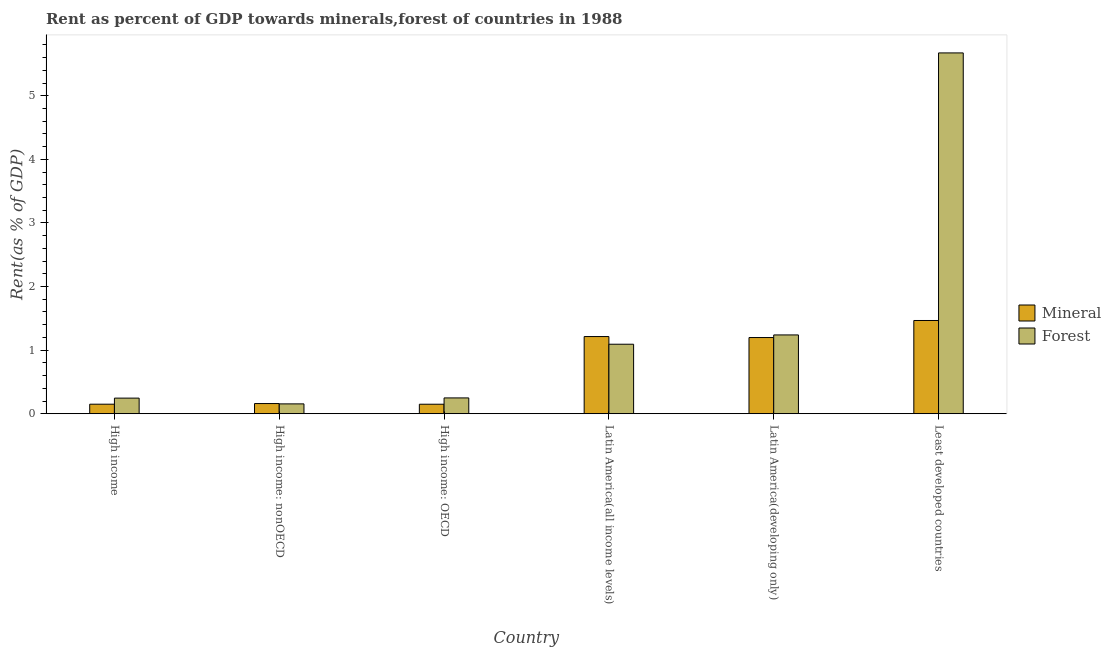How many bars are there on the 5th tick from the left?
Your answer should be compact. 2. How many bars are there on the 5th tick from the right?
Offer a very short reply. 2. What is the label of the 5th group of bars from the left?
Your response must be concise. Latin America(developing only). What is the mineral rent in High income?
Make the answer very short. 0.15. Across all countries, what is the maximum mineral rent?
Your response must be concise. 1.47. Across all countries, what is the minimum forest rent?
Offer a very short reply. 0.16. In which country was the forest rent maximum?
Your answer should be compact. Least developed countries. In which country was the forest rent minimum?
Provide a short and direct response. High income: nonOECD. What is the total forest rent in the graph?
Make the answer very short. 8.65. What is the difference between the mineral rent in High income: OECD and that in Least developed countries?
Keep it short and to the point. -1.32. What is the difference between the forest rent in Latin America(all income levels) and the mineral rent in Latin America(developing only)?
Your response must be concise. -0.11. What is the average mineral rent per country?
Provide a short and direct response. 0.72. What is the difference between the forest rent and mineral rent in High income: nonOECD?
Your response must be concise. -0.01. In how many countries, is the forest rent greater than 2 %?
Your answer should be compact. 1. What is the ratio of the mineral rent in High income to that in High income: nonOECD?
Provide a succinct answer. 0.94. Is the mineral rent in High income less than that in Least developed countries?
Ensure brevity in your answer.  Yes. Is the difference between the forest rent in High income and High income: nonOECD greater than the difference between the mineral rent in High income and High income: nonOECD?
Keep it short and to the point. Yes. What is the difference between the highest and the second highest forest rent?
Give a very brief answer. 4.43. What is the difference between the highest and the lowest forest rent?
Your answer should be compact. 5.52. What does the 1st bar from the left in Latin America(developing only) represents?
Your answer should be compact. Mineral. What does the 1st bar from the right in Latin America(developing only) represents?
Your answer should be very brief. Forest. How many countries are there in the graph?
Keep it short and to the point. 6. What is the difference between two consecutive major ticks on the Y-axis?
Keep it short and to the point. 1. Where does the legend appear in the graph?
Keep it short and to the point. Center right. How many legend labels are there?
Provide a succinct answer. 2. How are the legend labels stacked?
Offer a very short reply. Vertical. What is the title of the graph?
Provide a succinct answer. Rent as percent of GDP towards minerals,forest of countries in 1988. Does "Depositors" appear as one of the legend labels in the graph?
Provide a short and direct response. No. What is the label or title of the Y-axis?
Provide a succinct answer. Rent(as % of GDP). What is the Rent(as % of GDP) in Mineral in High income?
Ensure brevity in your answer.  0.15. What is the Rent(as % of GDP) in Forest in High income?
Offer a terse response. 0.25. What is the Rent(as % of GDP) in Mineral in High income: nonOECD?
Offer a very short reply. 0.16. What is the Rent(as % of GDP) of Forest in High income: nonOECD?
Your answer should be compact. 0.16. What is the Rent(as % of GDP) of Mineral in High income: OECD?
Make the answer very short. 0.15. What is the Rent(as % of GDP) of Forest in High income: OECD?
Give a very brief answer. 0.25. What is the Rent(as % of GDP) in Mineral in Latin America(all income levels)?
Provide a short and direct response. 1.21. What is the Rent(as % of GDP) in Forest in Latin America(all income levels)?
Give a very brief answer. 1.09. What is the Rent(as % of GDP) in Mineral in Latin America(developing only)?
Make the answer very short. 1.2. What is the Rent(as % of GDP) in Forest in Latin America(developing only)?
Offer a terse response. 1.24. What is the Rent(as % of GDP) of Mineral in Least developed countries?
Provide a succinct answer. 1.47. What is the Rent(as % of GDP) of Forest in Least developed countries?
Make the answer very short. 5.67. Across all countries, what is the maximum Rent(as % of GDP) of Mineral?
Provide a succinct answer. 1.47. Across all countries, what is the maximum Rent(as % of GDP) of Forest?
Offer a terse response. 5.67. Across all countries, what is the minimum Rent(as % of GDP) of Mineral?
Your response must be concise. 0.15. Across all countries, what is the minimum Rent(as % of GDP) in Forest?
Keep it short and to the point. 0.16. What is the total Rent(as % of GDP) in Mineral in the graph?
Your answer should be very brief. 4.34. What is the total Rent(as % of GDP) of Forest in the graph?
Make the answer very short. 8.65. What is the difference between the Rent(as % of GDP) in Mineral in High income and that in High income: nonOECD?
Offer a terse response. -0.01. What is the difference between the Rent(as % of GDP) in Forest in High income and that in High income: nonOECD?
Your response must be concise. 0.09. What is the difference between the Rent(as % of GDP) in Forest in High income and that in High income: OECD?
Offer a terse response. -0. What is the difference between the Rent(as % of GDP) in Mineral in High income and that in Latin America(all income levels)?
Make the answer very short. -1.06. What is the difference between the Rent(as % of GDP) in Forest in High income and that in Latin America(all income levels)?
Provide a short and direct response. -0.85. What is the difference between the Rent(as % of GDP) of Mineral in High income and that in Latin America(developing only)?
Provide a succinct answer. -1.05. What is the difference between the Rent(as % of GDP) of Forest in High income and that in Latin America(developing only)?
Provide a succinct answer. -0.99. What is the difference between the Rent(as % of GDP) in Mineral in High income and that in Least developed countries?
Offer a very short reply. -1.32. What is the difference between the Rent(as % of GDP) of Forest in High income and that in Least developed countries?
Provide a succinct answer. -5.43. What is the difference between the Rent(as % of GDP) of Mineral in High income: nonOECD and that in High income: OECD?
Provide a short and direct response. 0.01. What is the difference between the Rent(as % of GDP) in Forest in High income: nonOECD and that in High income: OECD?
Provide a succinct answer. -0.09. What is the difference between the Rent(as % of GDP) of Mineral in High income: nonOECD and that in Latin America(all income levels)?
Offer a very short reply. -1.05. What is the difference between the Rent(as % of GDP) in Forest in High income: nonOECD and that in Latin America(all income levels)?
Your response must be concise. -0.94. What is the difference between the Rent(as % of GDP) of Mineral in High income: nonOECD and that in Latin America(developing only)?
Offer a very short reply. -1.04. What is the difference between the Rent(as % of GDP) of Forest in High income: nonOECD and that in Latin America(developing only)?
Keep it short and to the point. -1.08. What is the difference between the Rent(as % of GDP) of Mineral in High income: nonOECD and that in Least developed countries?
Make the answer very short. -1.31. What is the difference between the Rent(as % of GDP) in Forest in High income: nonOECD and that in Least developed countries?
Give a very brief answer. -5.52. What is the difference between the Rent(as % of GDP) in Mineral in High income: OECD and that in Latin America(all income levels)?
Give a very brief answer. -1.06. What is the difference between the Rent(as % of GDP) in Forest in High income: OECD and that in Latin America(all income levels)?
Provide a succinct answer. -0.84. What is the difference between the Rent(as % of GDP) of Mineral in High income: OECD and that in Latin America(developing only)?
Give a very brief answer. -1.05. What is the difference between the Rent(as % of GDP) of Forest in High income: OECD and that in Latin America(developing only)?
Give a very brief answer. -0.99. What is the difference between the Rent(as % of GDP) of Mineral in High income: OECD and that in Least developed countries?
Provide a short and direct response. -1.32. What is the difference between the Rent(as % of GDP) in Forest in High income: OECD and that in Least developed countries?
Ensure brevity in your answer.  -5.42. What is the difference between the Rent(as % of GDP) of Mineral in Latin America(all income levels) and that in Latin America(developing only)?
Offer a very short reply. 0.02. What is the difference between the Rent(as % of GDP) of Forest in Latin America(all income levels) and that in Latin America(developing only)?
Your answer should be very brief. -0.15. What is the difference between the Rent(as % of GDP) in Mineral in Latin America(all income levels) and that in Least developed countries?
Keep it short and to the point. -0.25. What is the difference between the Rent(as % of GDP) in Forest in Latin America(all income levels) and that in Least developed countries?
Provide a succinct answer. -4.58. What is the difference between the Rent(as % of GDP) of Mineral in Latin America(developing only) and that in Least developed countries?
Ensure brevity in your answer.  -0.27. What is the difference between the Rent(as % of GDP) in Forest in Latin America(developing only) and that in Least developed countries?
Provide a short and direct response. -4.43. What is the difference between the Rent(as % of GDP) in Mineral in High income and the Rent(as % of GDP) in Forest in High income: nonOECD?
Your answer should be compact. -0.01. What is the difference between the Rent(as % of GDP) of Mineral in High income and the Rent(as % of GDP) of Forest in High income: OECD?
Your answer should be compact. -0.1. What is the difference between the Rent(as % of GDP) in Mineral in High income and the Rent(as % of GDP) in Forest in Latin America(all income levels)?
Give a very brief answer. -0.94. What is the difference between the Rent(as % of GDP) of Mineral in High income and the Rent(as % of GDP) of Forest in Latin America(developing only)?
Provide a short and direct response. -1.09. What is the difference between the Rent(as % of GDP) in Mineral in High income and the Rent(as % of GDP) in Forest in Least developed countries?
Your answer should be compact. -5.52. What is the difference between the Rent(as % of GDP) of Mineral in High income: nonOECD and the Rent(as % of GDP) of Forest in High income: OECD?
Offer a very short reply. -0.09. What is the difference between the Rent(as % of GDP) in Mineral in High income: nonOECD and the Rent(as % of GDP) in Forest in Latin America(all income levels)?
Keep it short and to the point. -0.93. What is the difference between the Rent(as % of GDP) in Mineral in High income: nonOECD and the Rent(as % of GDP) in Forest in Latin America(developing only)?
Your answer should be compact. -1.08. What is the difference between the Rent(as % of GDP) in Mineral in High income: nonOECD and the Rent(as % of GDP) in Forest in Least developed countries?
Ensure brevity in your answer.  -5.51. What is the difference between the Rent(as % of GDP) in Mineral in High income: OECD and the Rent(as % of GDP) in Forest in Latin America(all income levels)?
Offer a terse response. -0.94. What is the difference between the Rent(as % of GDP) in Mineral in High income: OECD and the Rent(as % of GDP) in Forest in Latin America(developing only)?
Make the answer very short. -1.09. What is the difference between the Rent(as % of GDP) of Mineral in High income: OECD and the Rent(as % of GDP) of Forest in Least developed countries?
Provide a short and direct response. -5.52. What is the difference between the Rent(as % of GDP) in Mineral in Latin America(all income levels) and the Rent(as % of GDP) in Forest in Latin America(developing only)?
Ensure brevity in your answer.  -0.03. What is the difference between the Rent(as % of GDP) in Mineral in Latin America(all income levels) and the Rent(as % of GDP) in Forest in Least developed countries?
Provide a succinct answer. -4.46. What is the difference between the Rent(as % of GDP) of Mineral in Latin America(developing only) and the Rent(as % of GDP) of Forest in Least developed countries?
Give a very brief answer. -4.48. What is the average Rent(as % of GDP) of Mineral per country?
Give a very brief answer. 0.72. What is the average Rent(as % of GDP) in Forest per country?
Provide a succinct answer. 1.44. What is the difference between the Rent(as % of GDP) of Mineral and Rent(as % of GDP) of Forest in High income?
Provide a short and direct response. -0.1. What is the difference between the Rent(as % of GDP) of Mineral and Rent(as % of GDP) of Forest in High income: nonOECD?
Your answer should be compact. 0.01. What is the difference between the Rent(as % of GDP) of Mineral and Rent(as % of GDP) of Forest in High income: OECD?
Provide a succinct answer. -0.1. What is the difference between the Rent(as % of GDP) of Mineral and Rent(as % of GDP) of Forest in Latin America(all income levels)?
Offer a terse response. 0.12. What is the difference between the Rent(as % of GDP) in Mineral and Rent(as % of GDP) in Forest in Latin America(developing only)?
Your answer should be compact. -0.04. What is the difference between the Rent(as % of GDP) of Mineral and Rent(as % of GDP) of Forest in Least developed countries?
Offer a very short reply. -4.21. What is the ratio of the Rent(as % of GDP) of Mineral in High income to that in High income: nonOECD?
Your response must be concise. 0.94. What is the ratio of the Rent(as % of GDP) in Forest in High income to that in High income: nonOECD?
Your answer should be very brief. 1.58. What is the ratio of the Rent(as % of GDP) of Forest in High income to that in High income: OECD?
Ensure brevity in your answer.  0.99. What is the ratio of the Rent(as % of GDP) of Mineral in High income to that in Latin America(all income levels)?
Offer a very short reply. 0.12. What is the ratio of the Rent(as % of GDP) in Forest in High income to that in Latin America(all income levels)?
Your answer should be compact. 0.22. What is the ratio of the Rent(as % of GDP) of Mineral in High income to that in Latin America(developing only)?
Make the answer very short. 0.13. What is the ratio of the Rent(as % of GDP) in Forest in High income to that in Latin America(developing only)?
Provide a short and direct response. 0.2. What is the ratio of the Rent(as % of GDP) of Mineral in High income to that in Least developed countries?
Ensure brevity in your answer.  0.1. What is the ratio of the Rent(as % of GDP) in Forest in High income to that in Least developed countries?
Give a very brief answer. 0.04. What is the ratio of the Rent(as % of GDP) in Mineral in High income: nonOECD to that in High income: OECD?
Keep it short and to the point. 1.07. What is the ratio of the Rent(as % of GDP) of Forest in High income: nonOECD to that in High income: OECD?
Provide a succinct answer. 0.62. What is the ratio of the Rent(as % of GDP) in Mineral in High income: nonOECD to that in Latin America(all income levels)?
Your answer should be compact. 0.13. What is the ratio of the Rent(as % of GDP) in Forest in High income: nonOECD to that in Latin America(all income levels)?
Offer a terse response. 0.14. What is the ratio of the Rent(as % of GDP) of Mineral in High income: nonOECD to that in Latin America(developing only)?
Offer a terse response. 0.13. What is the ratio of the Rent(as % of GDP) of Forest in High income: nonOECD to that in Latin America(developing only)?
Offer a terse response. 0.13. What is the ratio of the Rent(as % of GDP) of Mineral in High income: nonOECD to that in Least developed countries?
Provide a succinct answer. 0.11. What is the ratio of the Rent(as % of GDP) in Forest in High income: nonOECD to that in Least developed countries?
Give a very brief answer. 0.03. What is the ratio of the Rent(as % of GDP) of Mineral in High income: OECD to that in Latin America(all income levels)?
Provide a succinct answer. 0.12. What is the ratio of the Rent(as % of GDP) of Forest in High income: OECD to that in Latin America(all income levels)?
Ensure brevity in your answer.  0.23. What is the ratio of the Rent(as % of GDP) in Mineral in High income: OECD to that in Latin America(developing only)?
Provide a succinct answer. 0.12. What is the ratio of the Rent(as % of GDP) of Forest in High income: OECD to that in Latin America(developing only)?
Keep it short and to the point. 0.2. What is the ratio of the Rent(as % of GDP) of Mineral in High income: OECD to that in Least developed countries?
Your response must be concise. 0.1. What is the ratio of the Rent(as % of GDP) of Forest in High income: OECD to that in Least developed countries?
Ensure brevity in your answer.  0.04. What is the ratio of the Rent(as % of GDP) of Forest in Latin America(all income levels) to that in Latin America(developing only)?
Keep it short and to the point. 0.88. What is the ratio of the Rent(as % of GDP) in Mineral in Latin America(all income levels) to that in Least developed countries?
Provide a succinct answer. 0.83. What is the ratio of the Rent(as % of GDP) of Forest in Latin America(all income levels) to that in Least developed countries?
Your answer should be compact. 0.19. What is the ratio of the Rent(as % of GDP) of Mineral in Latin America(developing only) to that in Least developed countries?
Keep it short and to the point. 0.82. What is the ratio of the Rent(as % of GDP) of Forest in Latin America(developing only) to that in Least developed countries?
Keep it short and to the point. 0.22. What is the difference between the highest and the second highest Rent(as % of GDP) of Mineral?
Your answer should be very brief. 0.25. What is the difference between the highest and the second highest Rent(as % of GDP) of Forest?
Offer a very short reply. 4.43. What is the difference between the highest and the lowest Rent(as % of GDP) in Mineral?
Your response must be concise. 1.32. What is the difference between the highest and the lowest Rent(as % of GDP) in Forest?
Give a very brief answer. 5.52. 